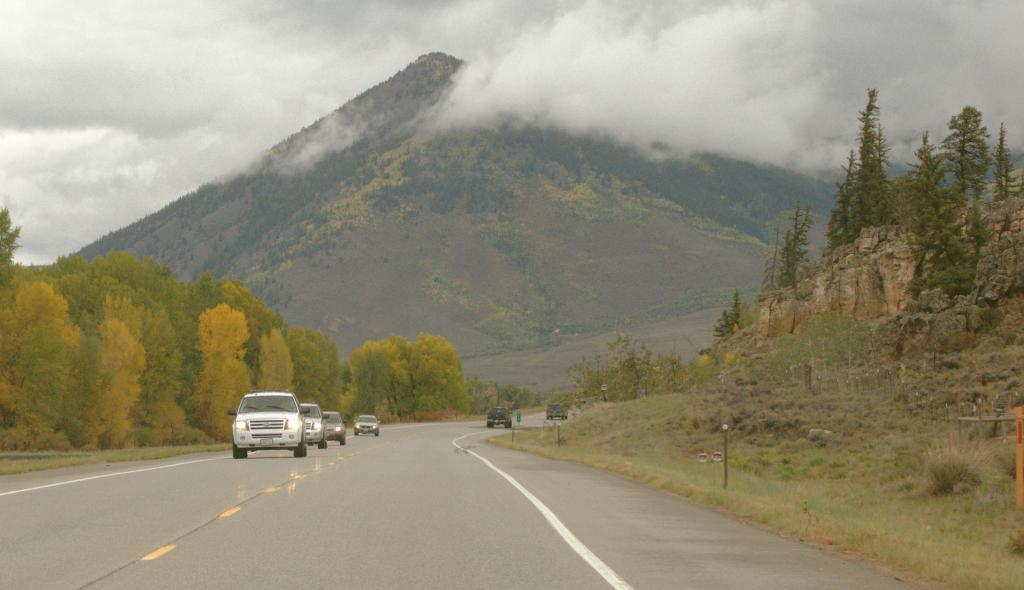What can be seen on the road in the image? There are vehicles on the road in the image. What type of vegetation is present in the image? There are trees with green color in the image. What structures can be seen in the image? There are poles in the image. What is the color of the sky in the background of the image? The sky is in white color in the background of the image. Are there any badges visible on the vehicles in the image? There is no information about badges on the vehicles in the image. How many houses can be seen in the image? There is no mention of houses in the image; it features vehicles, trees, poles, and a white sky. 